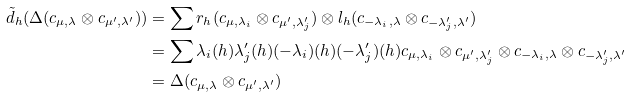Convert formula to latex. <formula><loc_0><loc_0><loc_500><loc_500>\tilde { d } _ { h } ( \Delta ( c _ { \mu , \lambda } \otimes c _ { \mu ^ { \prime } , \lambda ^ { \prime } } ) ) & = \sum r _ { h } ( c _ { \mu , \lambda _ { i } } \otimes c _ { \mu ^ { \prime } , \lambda ^ { \prime } _ { j } } ) \otimes l _ { h } ( c _ { - \lambda _ { i } , \lambda } \otimes c _ { - \lambda _ { j } ^ { \prime } , \lambda ^ { \prime } } ) \\ & = \sum \lambda _ { i } ( h ) \lambda _ { j } ^ { \prime } ( h ) ( - \lambda _ { i } ) ( h ) ( - \lambda _ { j } ^ { \prime } ) ( h ) c _ { \mu , \lambda _ { i } } \otimes c _ { \mu ^ { \prime } , \lambda ^ { \prime } _ { j } } \otimes c _ { - \lambda _ { i } , \lambda } \otimes c _ { - \lambda _ { j } ^ { \prime } , \lambda ^ { \prime } } \\ & = \Delta ( c _ { \mu , \lambda } \otimes c _ { \mu ^ { \prime } , \lambda ^ { \prime } } )</formula> 